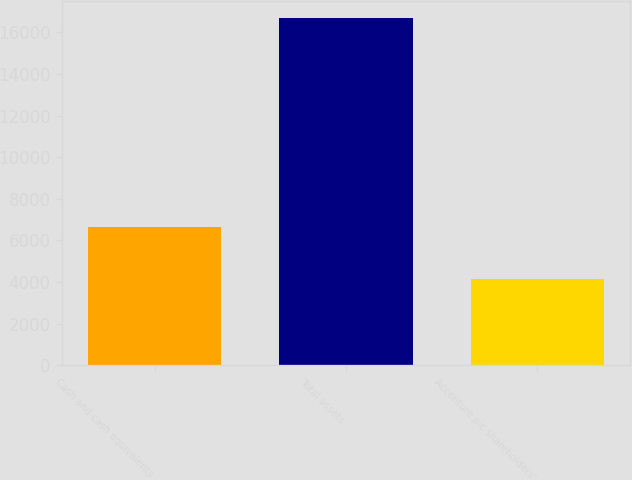<chart> <loc_0><loc_0><loc_500><loc_500><bar_chart><fcel>Cash and cash equivalents<fcel>Total assets<fcel>Accenture plc shareholders'<nl><fcel>6641<fcel>16665<fcel>4146<nl></chart> 